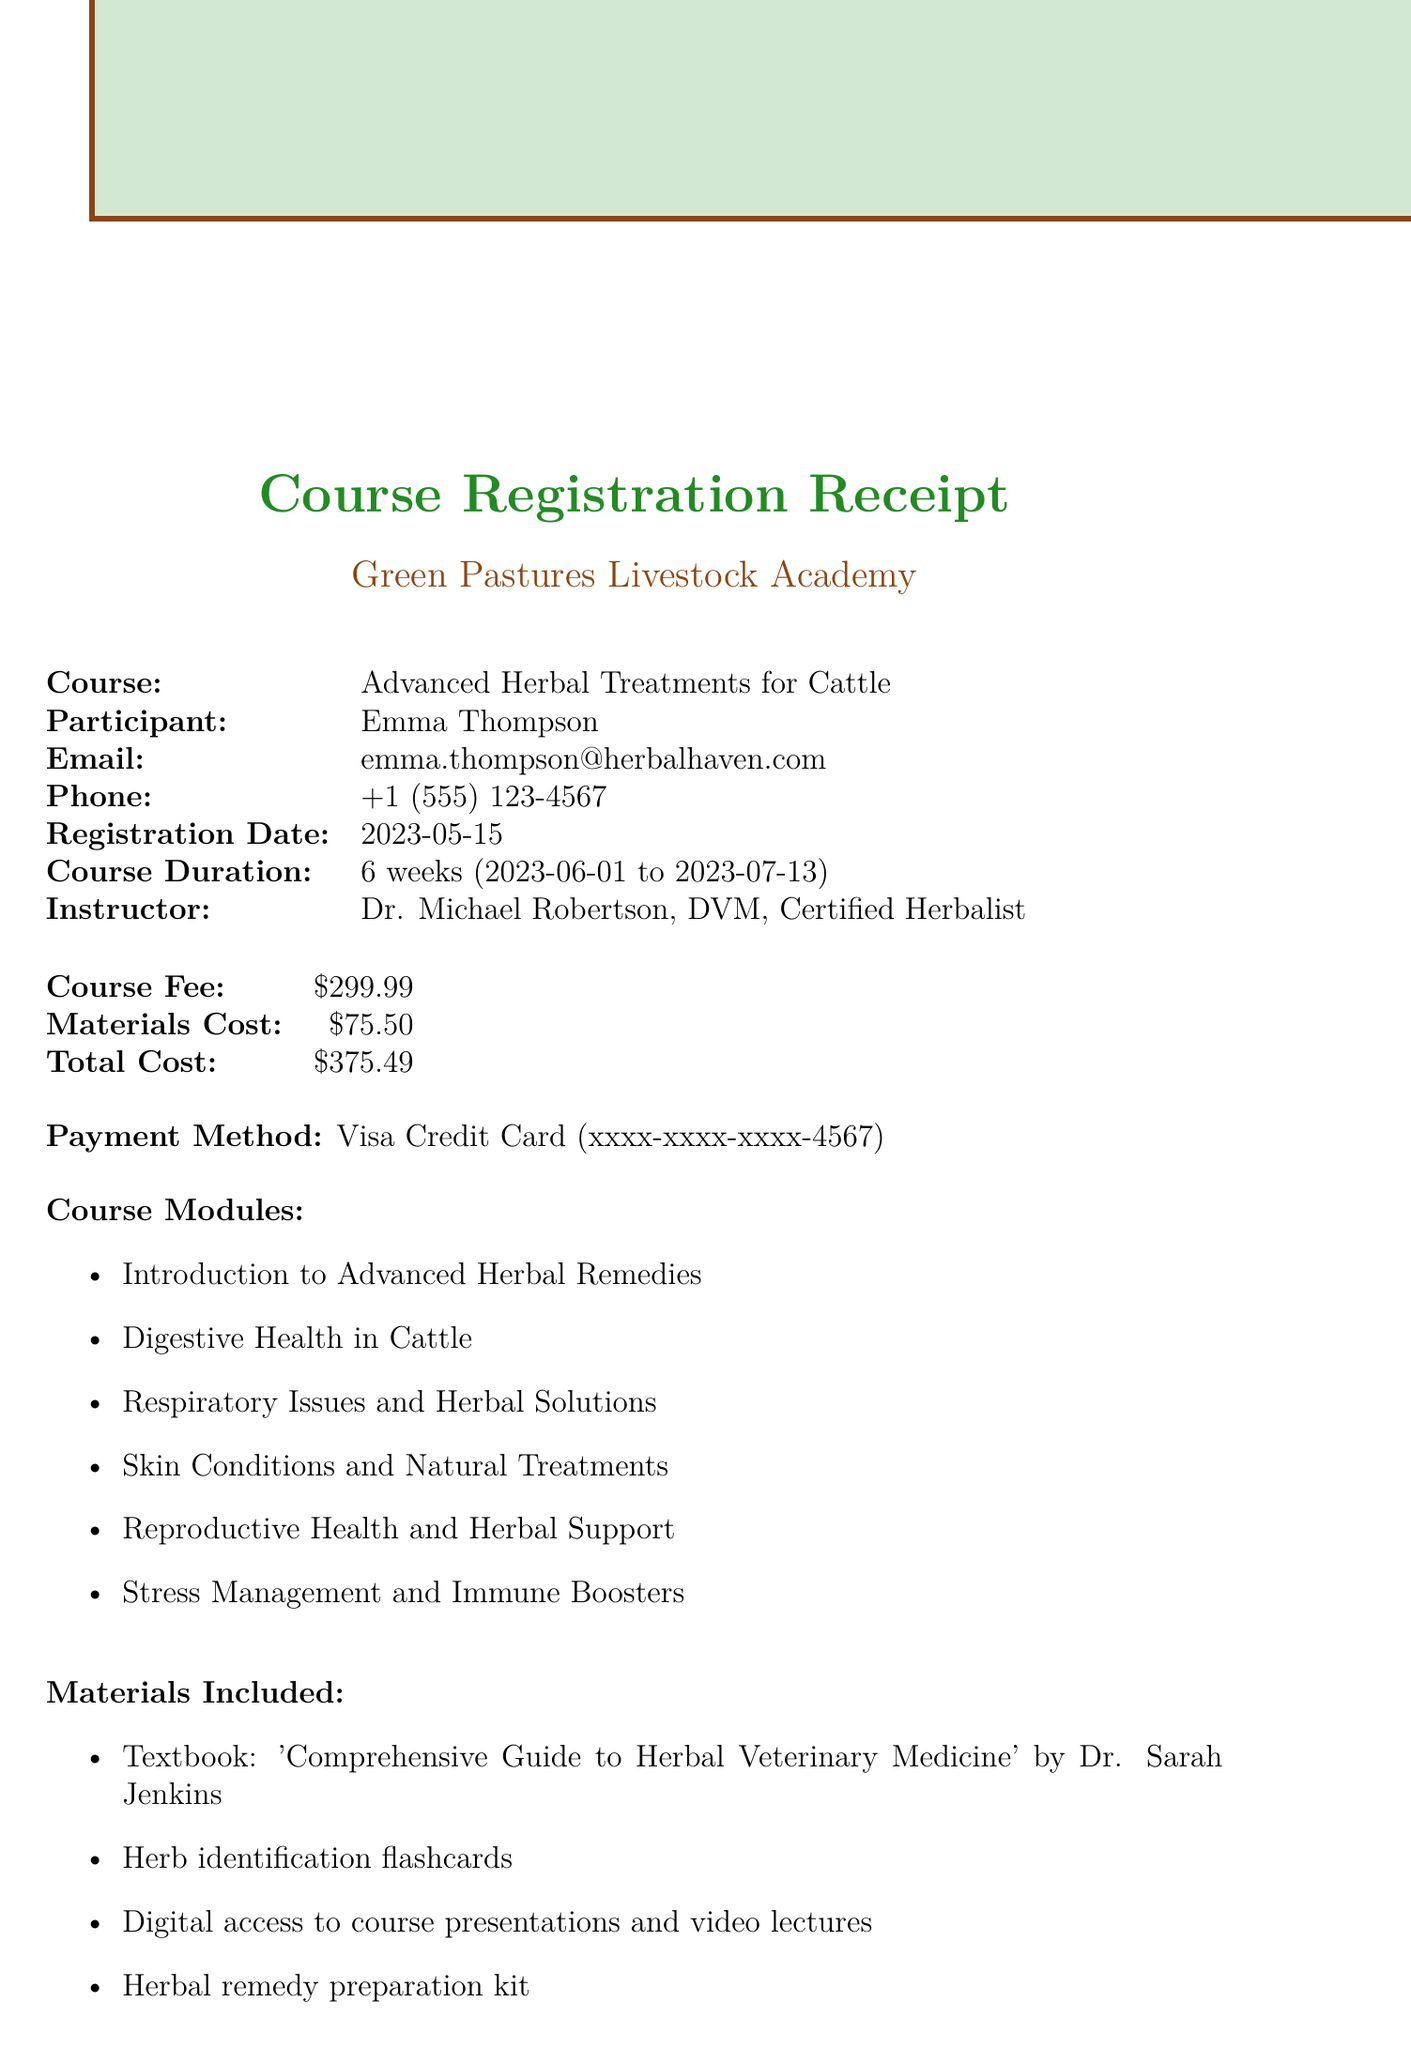What is the name of the course? The course name is specified in the document as the main focus of the registration receipt.
Answer: Advanced Herbal Treatments for Cattle Who is the instructor of the course? The document lists the instructor's name, which is essential for participants to know who will be teaching them.
Answer: Dr. Michael Robertson, DVM, Certified Herbalist What is the total cost for the course? The total cost is explicitly mentioned in the financial section of the document.
Answer: $375.49 When does the course start? The start date of the course is critical for participants to know when to begin their education.
Answer: 2023-06-01 What materials are included? The list of materials included helps participants understand what they will receive as part of the course.
Answer: Textbook, herb identification flashcards, digital access, preparation kit What is the duration of the course? The duration indicates how long participants will be engaged in the course content.
Answer: 6 weeks What is the refund policy? The refund policy explains the conditions under which participants can get their money back, which is important for financial planning.
Answer: Full refund available within 7 days of course start date What payment method was used for the registration? The payment method shows how the participant paid for the course and may be relevant for accounting purposes.
Answer: Credit Card What is the transaction ID? The transaction ID is unique to this specific registration and can be used for future reference or inquiry.
Answer: GPA-23051501 